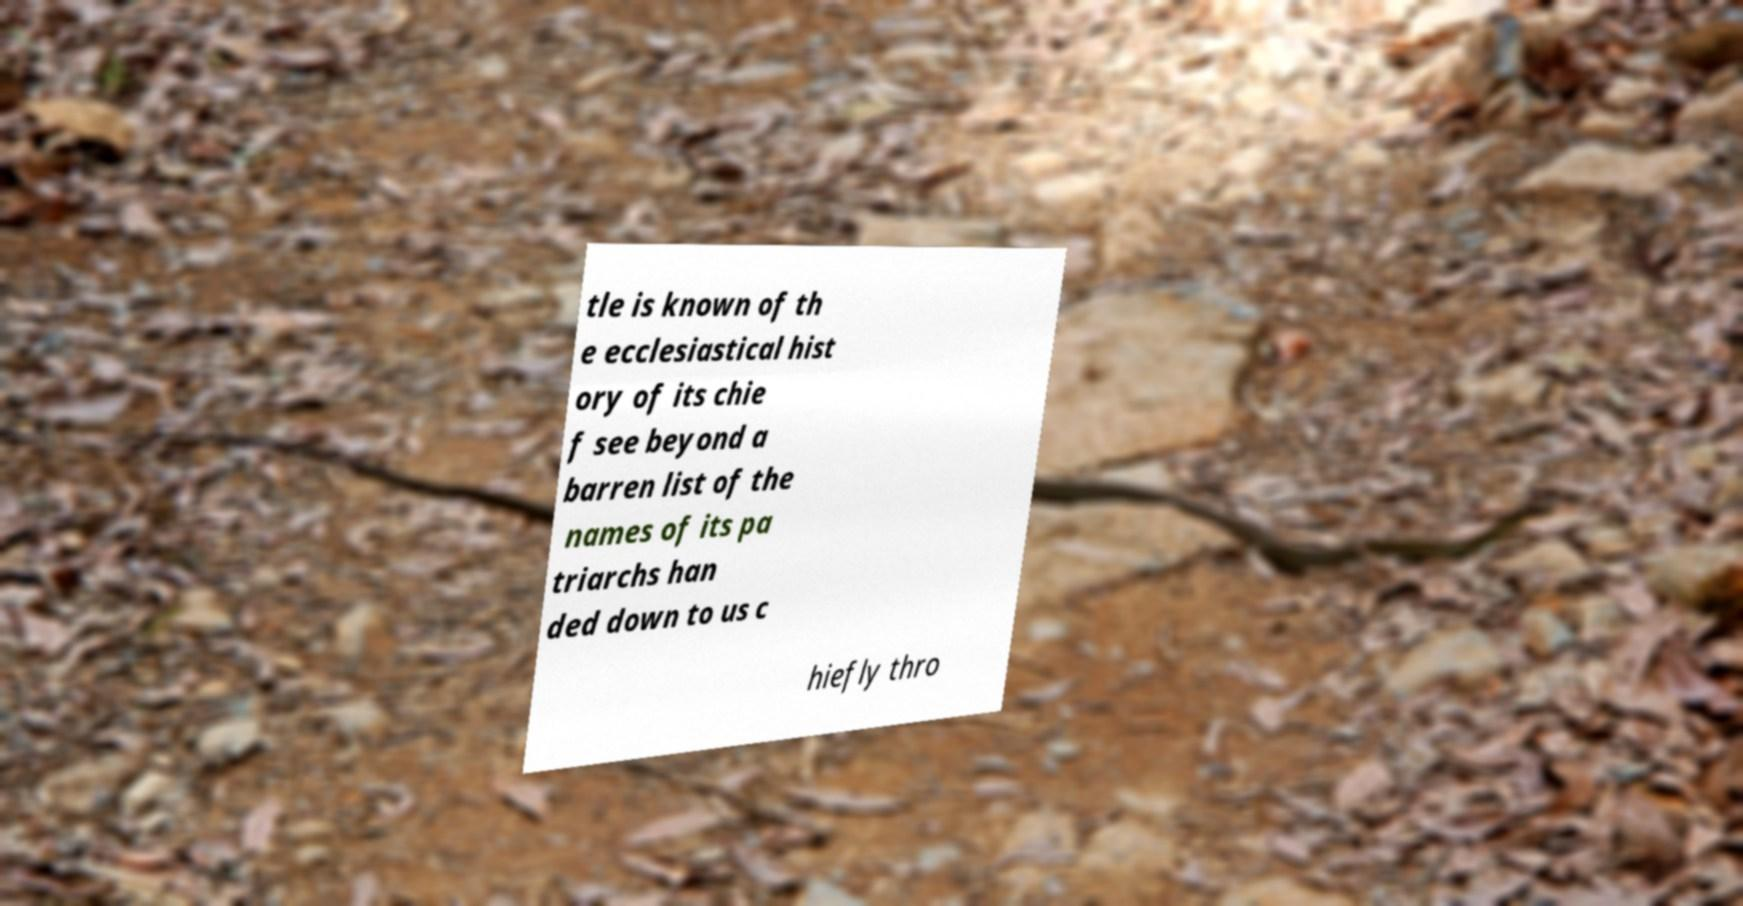Could you extract and type out the text from this image? tle is known of th e ecclesiastical hist ory of its chie f see beyond a barren list of the names of its pa triarchs han ded down to us c hiefly thro 